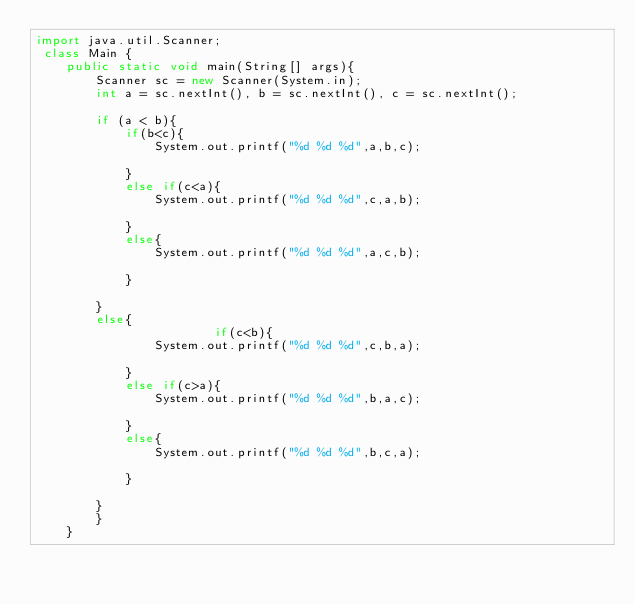Convert code to text. <code><loc_0><loc_0><loc_500><loc_500><_Java_>import java.util.Scanner;
 class Main {
    public static void main(String[] args){
        Scanner sc = new Scanner(System.in);
        int a = sc.nextInt(), b = sc.nextInt(), c = sc.nextInt();
 
        if (a < b){
        	if(b<c){
        		System.out.printf("%d %d %d",a,b,c);

        	}
        	else if(c<a){
        		System.out.printf("%d %d %d",c,a,b);

        	}
        	else{
        		System.out.printf("%d %d %d",a,c,b);

        	}
        	    
        }
        else{
        	        	if(c<b){
        		System.out.printf("%d %d %d",c,b,a);

        	}
        	else if(c>a){
        		System.out.printf("%d %d %d",b,a,c);

        	}
        	else{
        		System.out.printf("%d %d %d",b,c,a);

        	}

        }
        }
    }</code> 